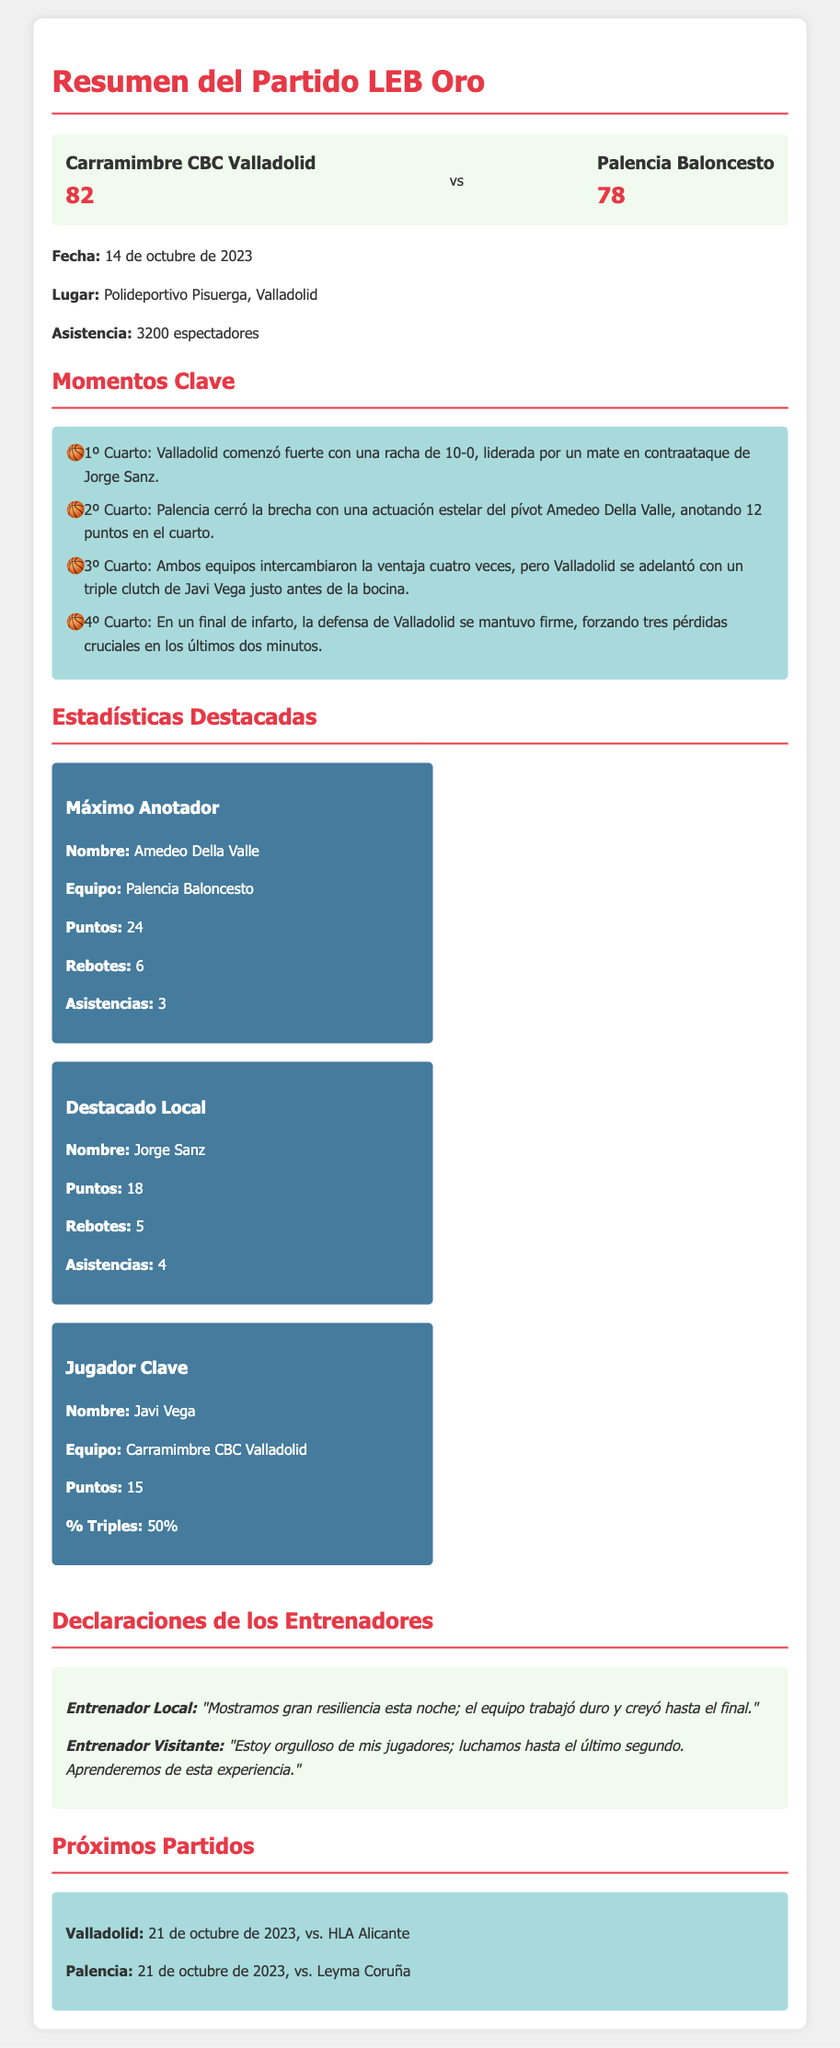¿Cuál fue el marcador final del partido? El marcador final del partido fue el resultado final de las dos equipos.
Answer: 82-78 ¿Qué equipo fue el máximo anotador del partido? El máximo anotador del partido fue el jugador que anotó la mayor cantidad de puntos.
Answer: Amedeo Della Valle ¿Cuántos puntos anotó Jorge Sanz? Jorge Sanz aportó puntos al equipo local, que son especificados en las estadísticas.
Answer: 18 ¿Cuál fue la fecha del partido? La fecha del partido se menciona claramente en el documento.
Answer: 14 de octubre de 2023 ¿Qué equipo tuvo más pérdidas en el cuarto final? Se informa que el equipo que tuvo problemas en los últimos minutos es mencionado en el resumen del partido.
Answer: Palencia Baloncesto ¿Cuántas personas asistieron al partido? La asistencia se menciona en una de las secciones que describe el evento.
Answer: 3200 espectadores ¿Qué jugador fue destacado por el equipo local? En las estadísticas, se señala un jugador que sobresalió en el equipo local.
Answer: Jorge Sanz ¿Cuándo es el próximo partido de Valladolid? La fecha del próximo partido de Valladolid se proporciona en la sección correspondiente.
Answer: 21 de octubre de 2023 